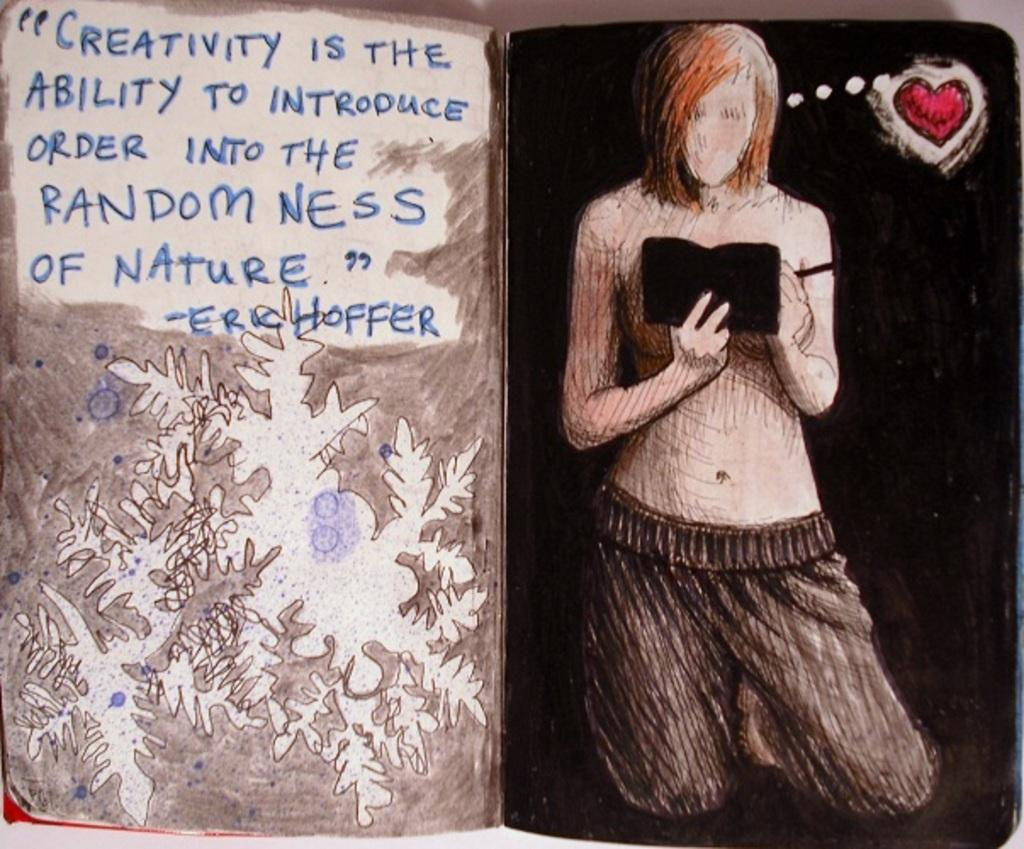What object is present in the image that contains written information? There is a book in the image that contains text. Can you describe the picture within the image? The picture in the image shows a man holding a book. What type of visual element is present in the image besides the picture? There is some form of art in the image. How many cars are parked in front of the man holding the book in the image? There are no cars present in the image; it only shows a man holding a book and some form of art. 